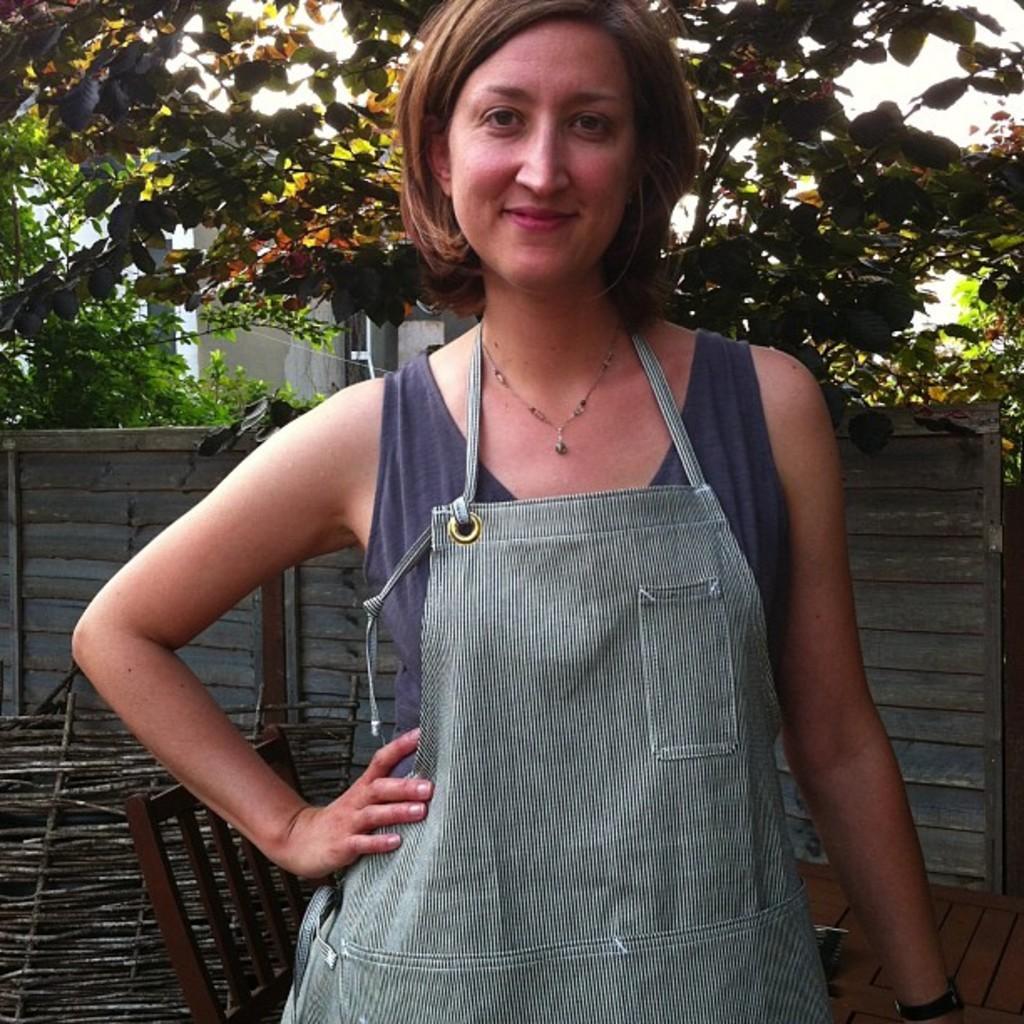Describe this image in one or two sentences. In this picture we can see a woman standing and smiling and in the background we can see fence, trees, chair. 